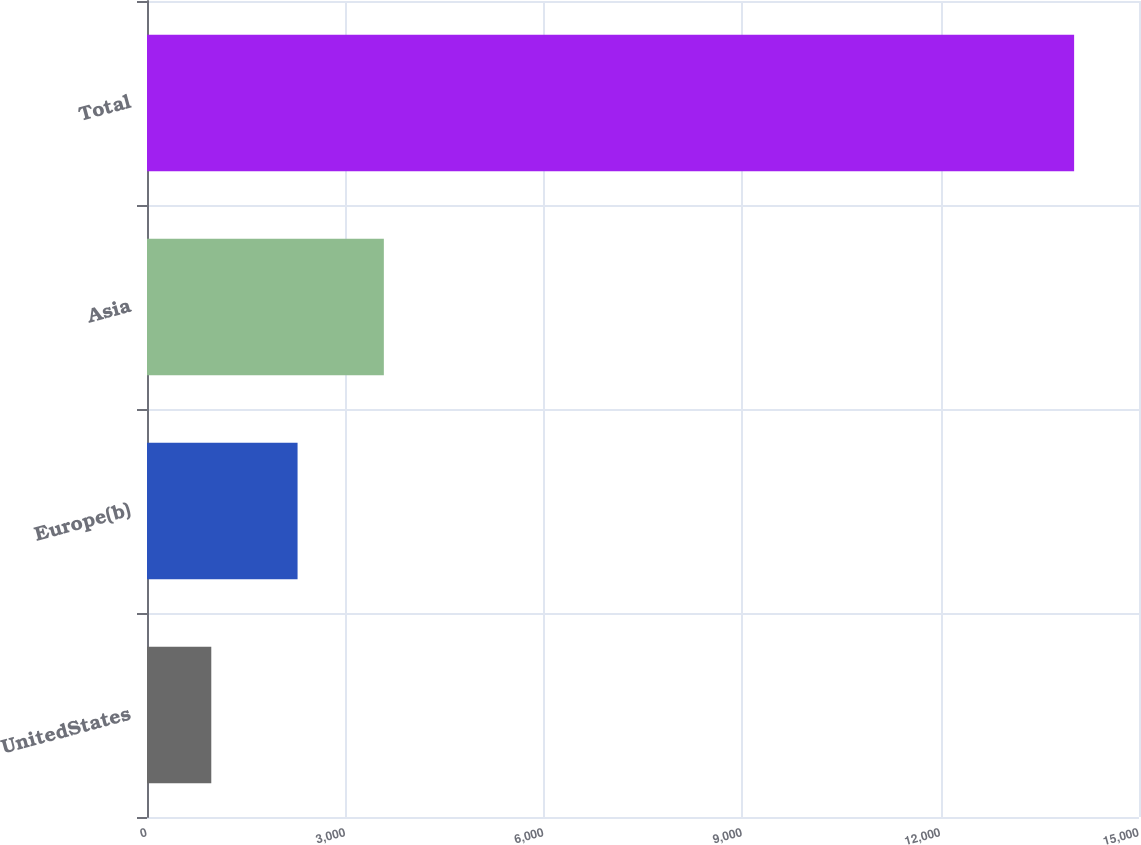Convert chart. <chart><loc_0><loc_0><loc_500><loc_500><bar_chart><fcel>UnitedStates<fcel>Europe(b)<fcel>Asia<fcel>Total<nl><fcel>972<fcel>2276.7<fcel>3581.4<fcel>14019<nl></chart> 